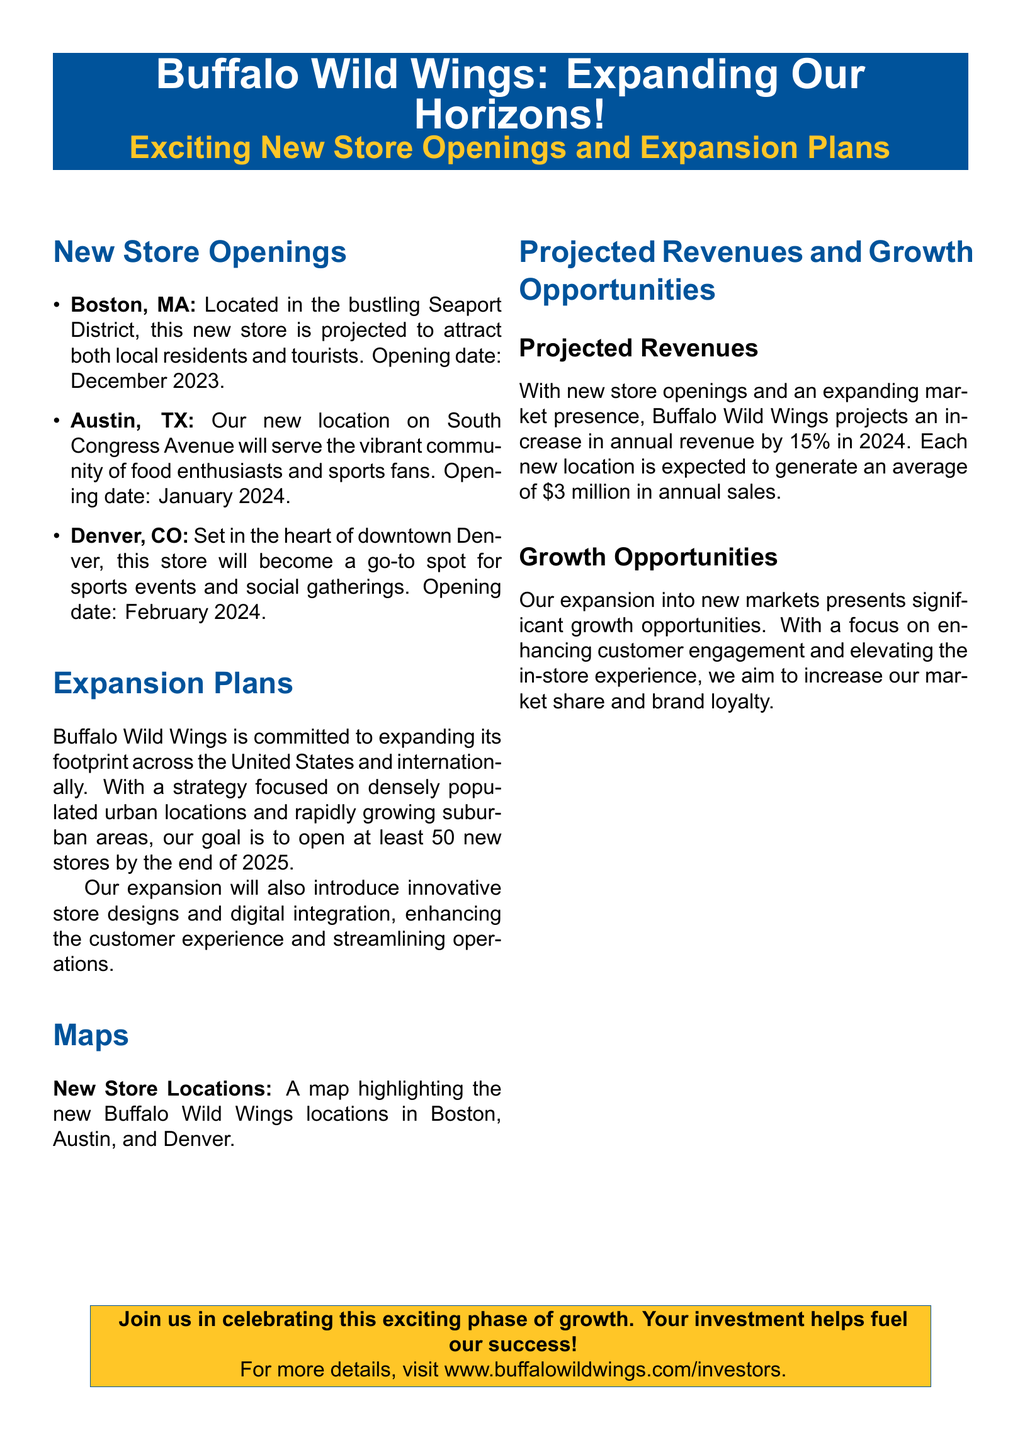What are the new store locations? The document lists three new store locations: Boston, MA; Austin, TX; and Denver, CO.
Answer: Boston, MA; Austin, TX; Denver, CO When is the opening date for the Boston store? The document specifies that the Boston store is projected to open in December 2023.
Answer: December 2023 What is the expected increase in annual revenue for 2024? The document indicates that Buffalo Wild Wings projects a 15% increase in annual revenue for 2024.
Answer: 15% How many new stores does Buffalo Wild Wings aim to open by the end of 2025? According to the document, the company aims to open at least 50 new stores by the end of 2025.
Answer: 50 What average annual sales is each new location expected to generate? The document states that each new location is expected to generate an average of $3 million in annual sales.
Answer: $3 million What type of areas is Buffalo Wild Wings focusing on for its expansion? The document mentions that the focus is on densely populated urban locations and rapidly growing suburban areas.
Answer: Urban locations and suburban areas What innovative features are included in the expansion plans? The document highlights the introduction of innovative store designs and digital integration to enhance customer experience.
Answer: Innovative store designs and digital integration What is the main goal of the expansion according to the document? The document states that the primary goal of the expansion is to increase market share and brand loyalty.
Answer: Increase market share and brand loyalty 